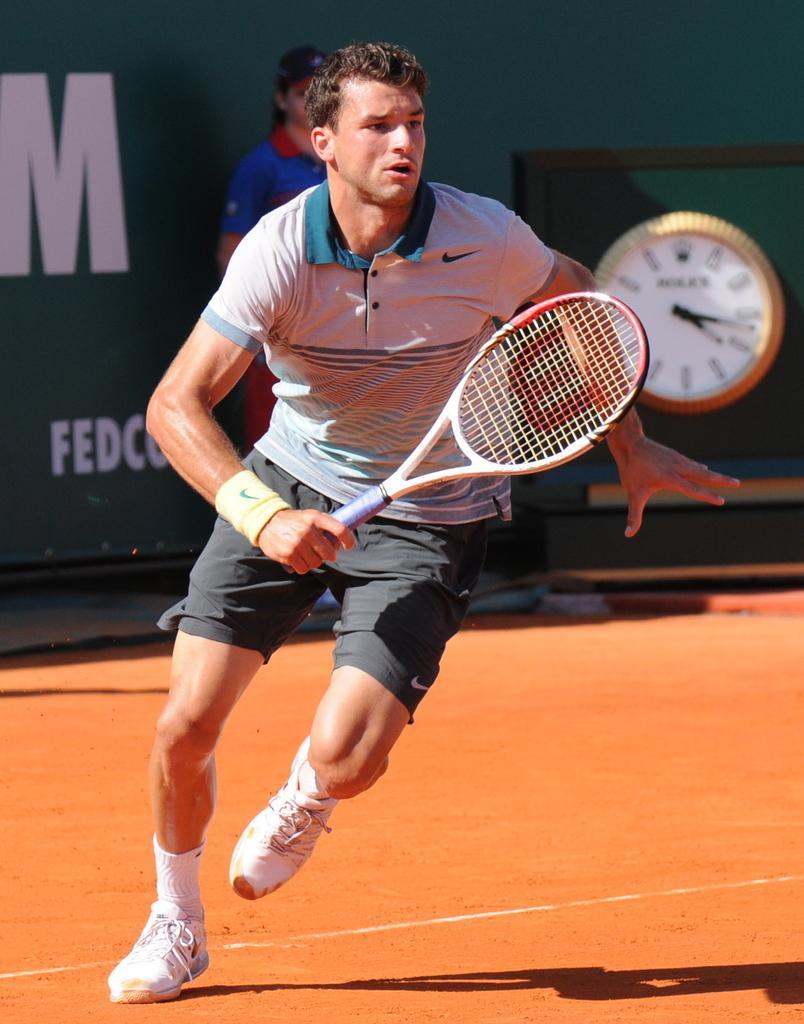How would you summarize this image in a sentence or two? Here we can see a man in motion with a racket in his hand, behind him we can see a woman standing and a clock present 